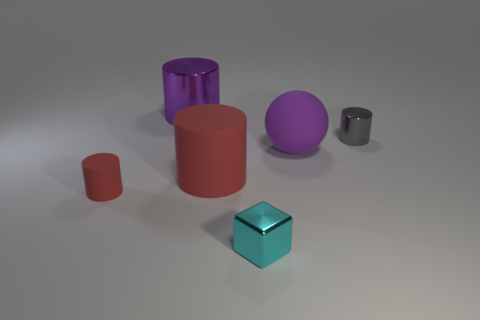What number of things are purple spheres or purple things that are in front of the gray cylinder?
Your response must be concise. 1. What is the material of the other big thing that is the same shape as the large purple metallic thing?
Provide a succinct answer. Rubber. Is there anything else that is made of the same material as the large red object?
Provide a short and direct response. Yes. The object that is both left of the tiny gray thing and behind the purple sphere is made of what material?
Ensure brevity in your answer.  Metal. How many purple things are the same shape as the tiny red object?
Offer a terse response. 1. The big rubber cylinder behind the metallic object that is in front of the gray cylinder is what color?
Make the answer very short. Red. Are there an equal number of tiny blocks to the right of the big red rubber thing and green matte things?
Ensure brevity in your answer.  No. Are there any purple matte things that have the same size as the purple rubber ball?
Your answer should be very brief. No. There is a gray metal thing; is its size the same as the rubber cylinder that is in front of the big red cylinder?
Your answer should be very brief. Yes. Are there an equal number of spheres left of the large metal object and rubber things to the left of the tiny red thing?
Keep it short and to the point. Yes. 